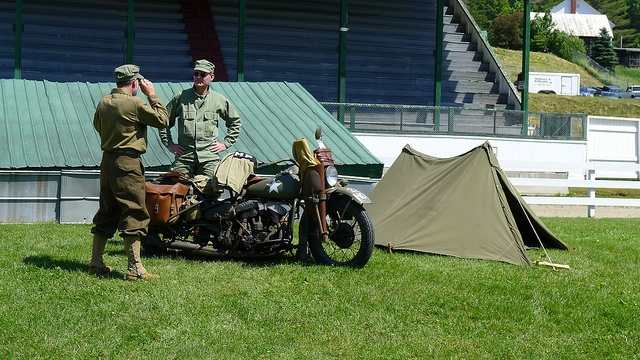Describe the objects in this image and their specific colors. I can see motorcycle in black, gray, darkgray, and darkgreen tones, people in black, tan, darkgreen, and gray tones, people in black, darkgray, gray, and beige tones, backpack in black, beige, and darkgray tones, and truck in black, white, darkgray, and gray tones in this image. 